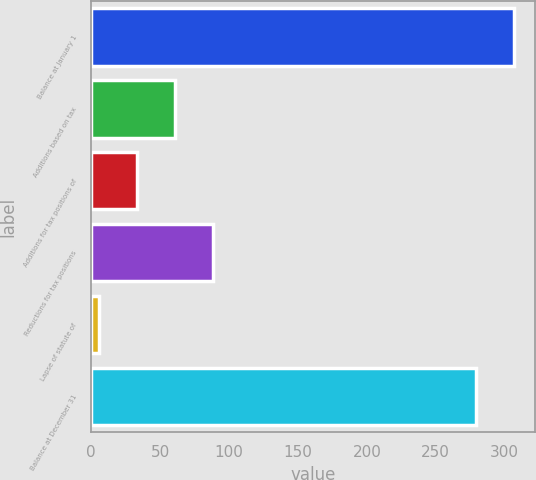Convert chart. <chart><loc_0><loc_0><loc_500><loc_500><bar_chart><fcel>Balance at January 1<fcel>Additions based on tax<fcel>Additions for tax positions of<fcel>Reductions for tax positions<fcel>Lapse of statute of<fcel>Balance at December 31<nl><fcel>306.4<fcel>60.8<fcel>33.4<fcel>88.2<fcel>6<fcel>279<nl></chart> 